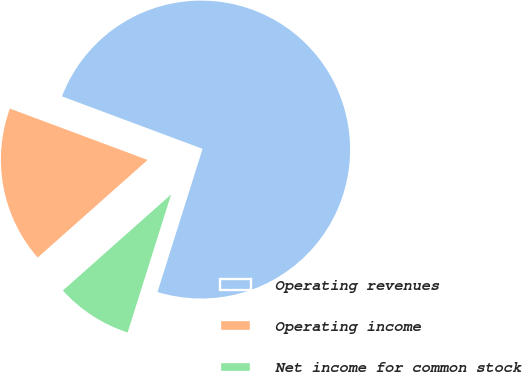Convert chart. <chart><loc_0><loc_0><loc_500><loc_500><pie_chart><fcel>Operating revenues<fcel>Operating income<fcel>Net income for common stock<nl><fcel>74.17%<fcel>17.24%<fcel>8.59%<nl></chart> 